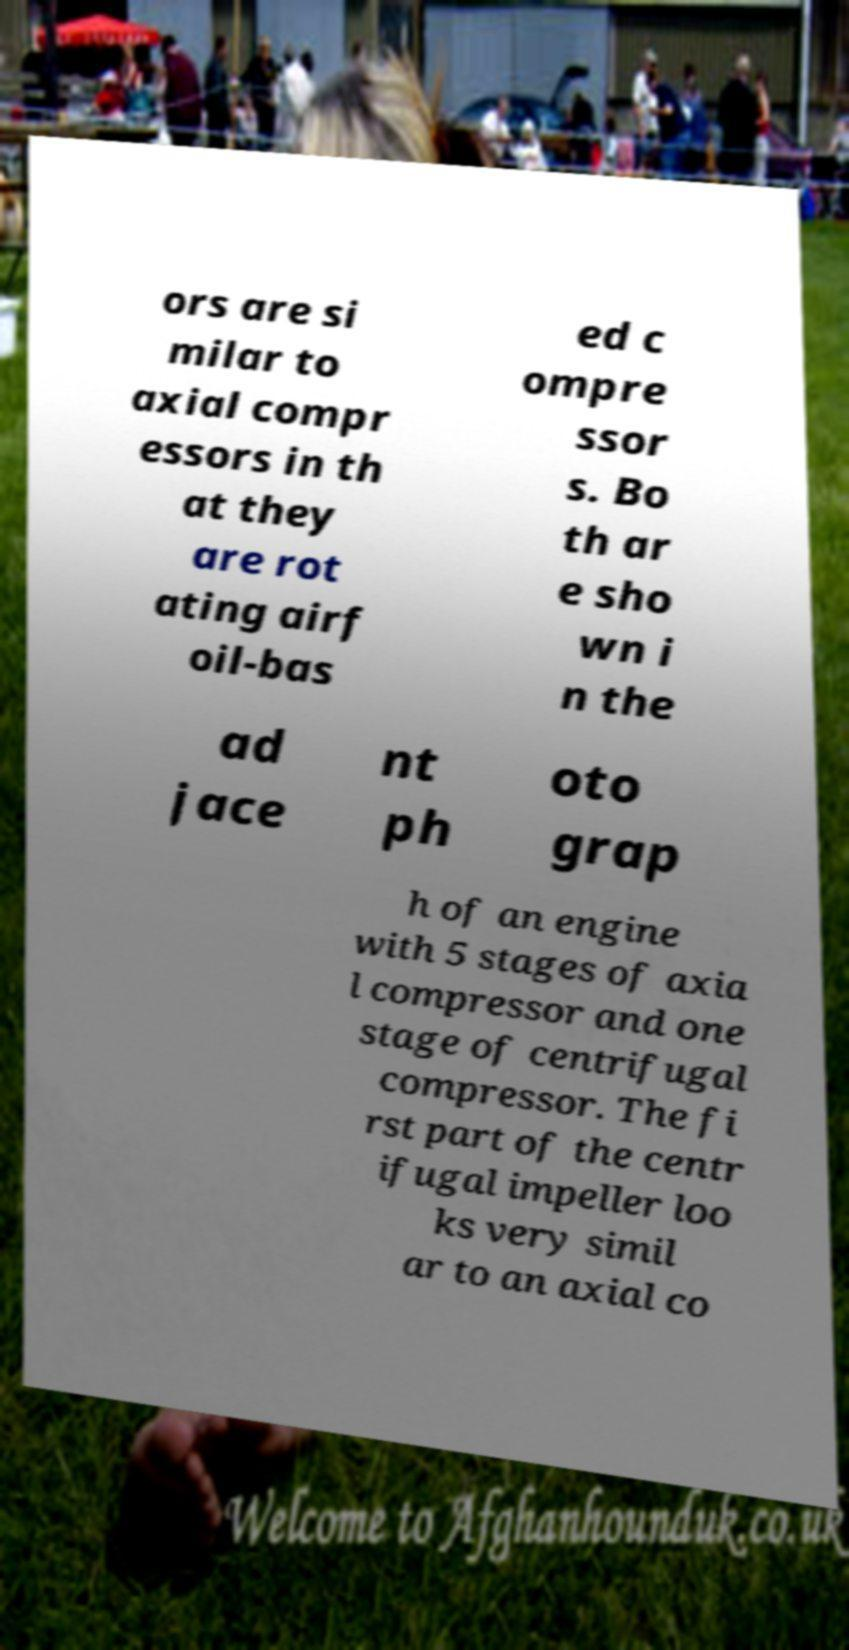There's text embedded in this image that I need extracted. Can you transcribe it verbatim? ors are si milar to axial compr essors in th at they are rot ating airf oil-bas ed c ompre ssor s. Bo th ar e sho wn i n the ad jace nt ph oto grap h of an engine with 5 stages of axia l compressor and one stage of centrifugal compressor. The fi rst part of the centr ifugal impeller loo ks very simil ar to an axial co 